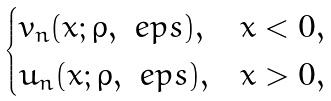<formula> <loc_0><loc_0><loc_500><loc_500>\begin{cases} v _ { n } ( x ; \rho , \ e p s ) , & x < 0 , \\ u _ { n } ( x ; \rho , \ e p s ) , & x > 0 , \end{cases}</formula> 